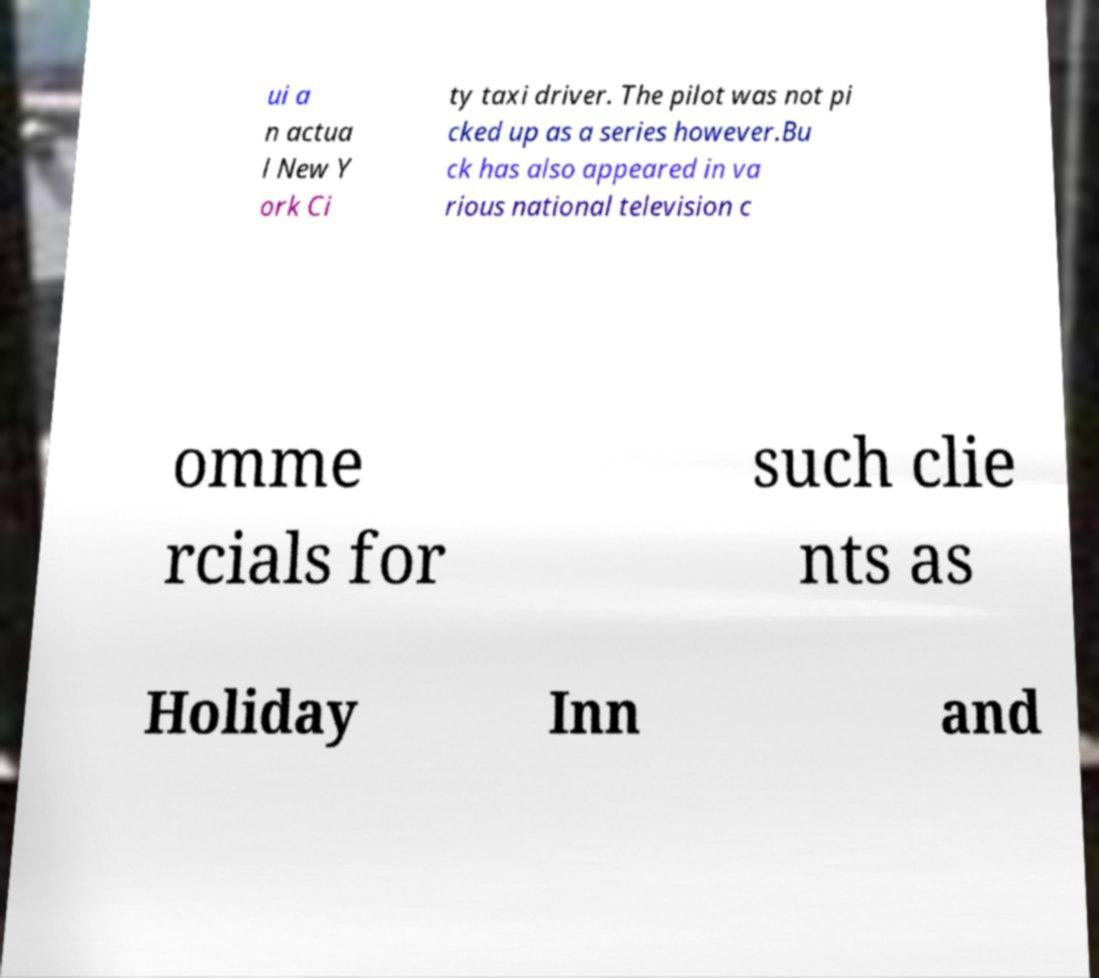For documentation purposes, I need the text within this image transcribed. Could you provide that? ui a n actua l New Y ork Ci ty taxi driver. The pilot was not pi cked up as a series however.Bu ck has also appeared in va rious national television c omme rcials for such clie nts as Holiday Inn and 